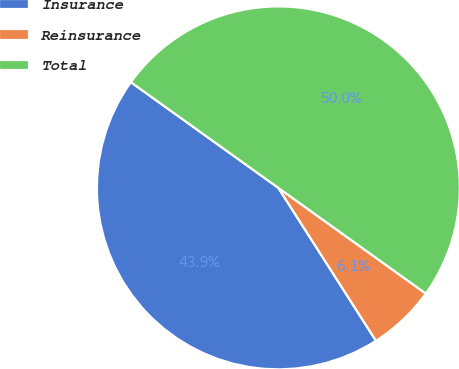<chart> <loc_0><loc_0><loc_500><loc_500><pie_chart><fcel>Insurance<fcel>Reinsurance<fcel>Total<nl><fcel>43.94%<fcel>6.06%<fcel>50.0%<nl></chart> 